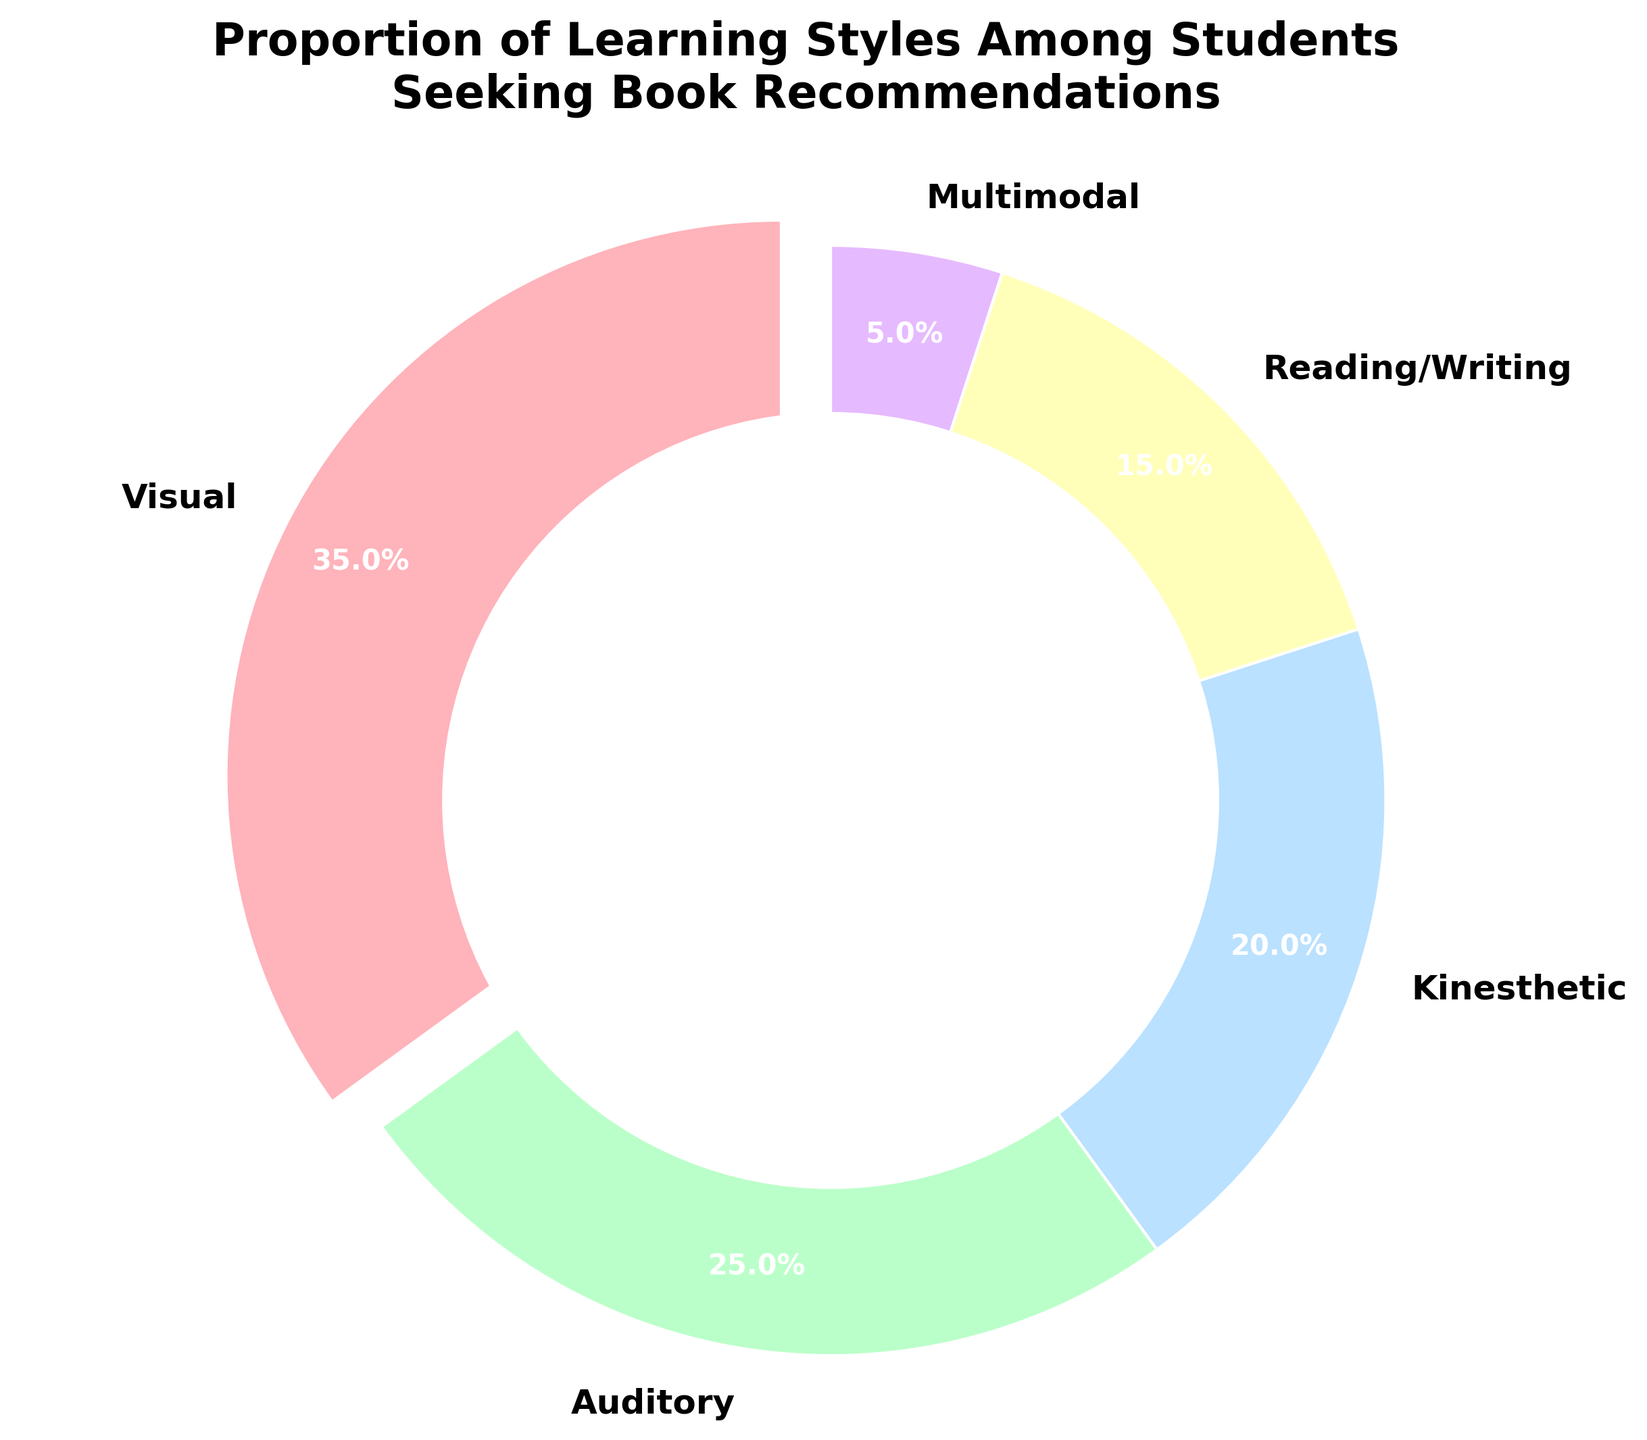What is the most common learning style among students seeking book recommendations? The largest slice of the pie chart represents the visual learning style, which has been highlighted by being "exploded" slightly from the rest of the pie. This visual cue clearly indicates it is the most common.
Answer: Visual Which two learning styles have a combined proportion of 45%? The pie chart shows that the auditory learning style is 25%, and the kinesthetic learning style is 20%. Adding these two percentages together gives 45%.
Answer: Auditory and Kinesthetic What is the least common learning style among students seeking book recommendations? The smallest slice of the pie chart represents the multimodal learning style, with a proportion of 5%.
Answer: Multimodal How much larger is the proportion of visual learners compared to reading/writing learners? The visual learning style makes up 35%, while the reading/writing learning style makes up 15%. Subtracting these two percentages gives 20%.
Answer: 20% Which learning style represents a smaller percentage, kinesthetic or reading/writing? The pie chart shows that reading/writing learning style is 15%, and kinesthetic is 20%. Therefore, reading/writing is smaller.
Answer: Reading/Writing What percentage of students prefer visual or auditory learning styles combined? The visual learning style is 35%, and the auditory learning style is 25%. Adding these two together gives a combined percentage of 60%.
Answer: 60% By how much does the percentage of auditory learners exceed that of multimodal learners? The auditory learning style makes up 25% of the pie chart, whereas the multimodal learning style makes up 5%. The difference between these is 20%.
Answer: 20% If you combine the kinesthetic and multimodal learning styles, do they surpass the proportion of visual learners? Kinesthetic is 20% and multimodal is 5%, which together add up to 25%. Since visual learners make up 35%, the combined percentage of kinesthetic and multimodal does not surpass visual learners.
Answer: No How does the percentage of kinesthetic learners compare to the average percentage of all learning styles? First, calculate the average percentage: (35% + 25% + 20% + 15% + 5%) / 5 = 20%. The percentage of kinesthetic learners is 20%, which is equal to the average.
Answer: Equal If you were to recommend a book that caters to both visual and reading/writing learners, what percentage of students would you be targeting? The visual learning style is 35%, and the reading/writing learning style is 15%. Adding these together gives 50%.
Answer: 50% 